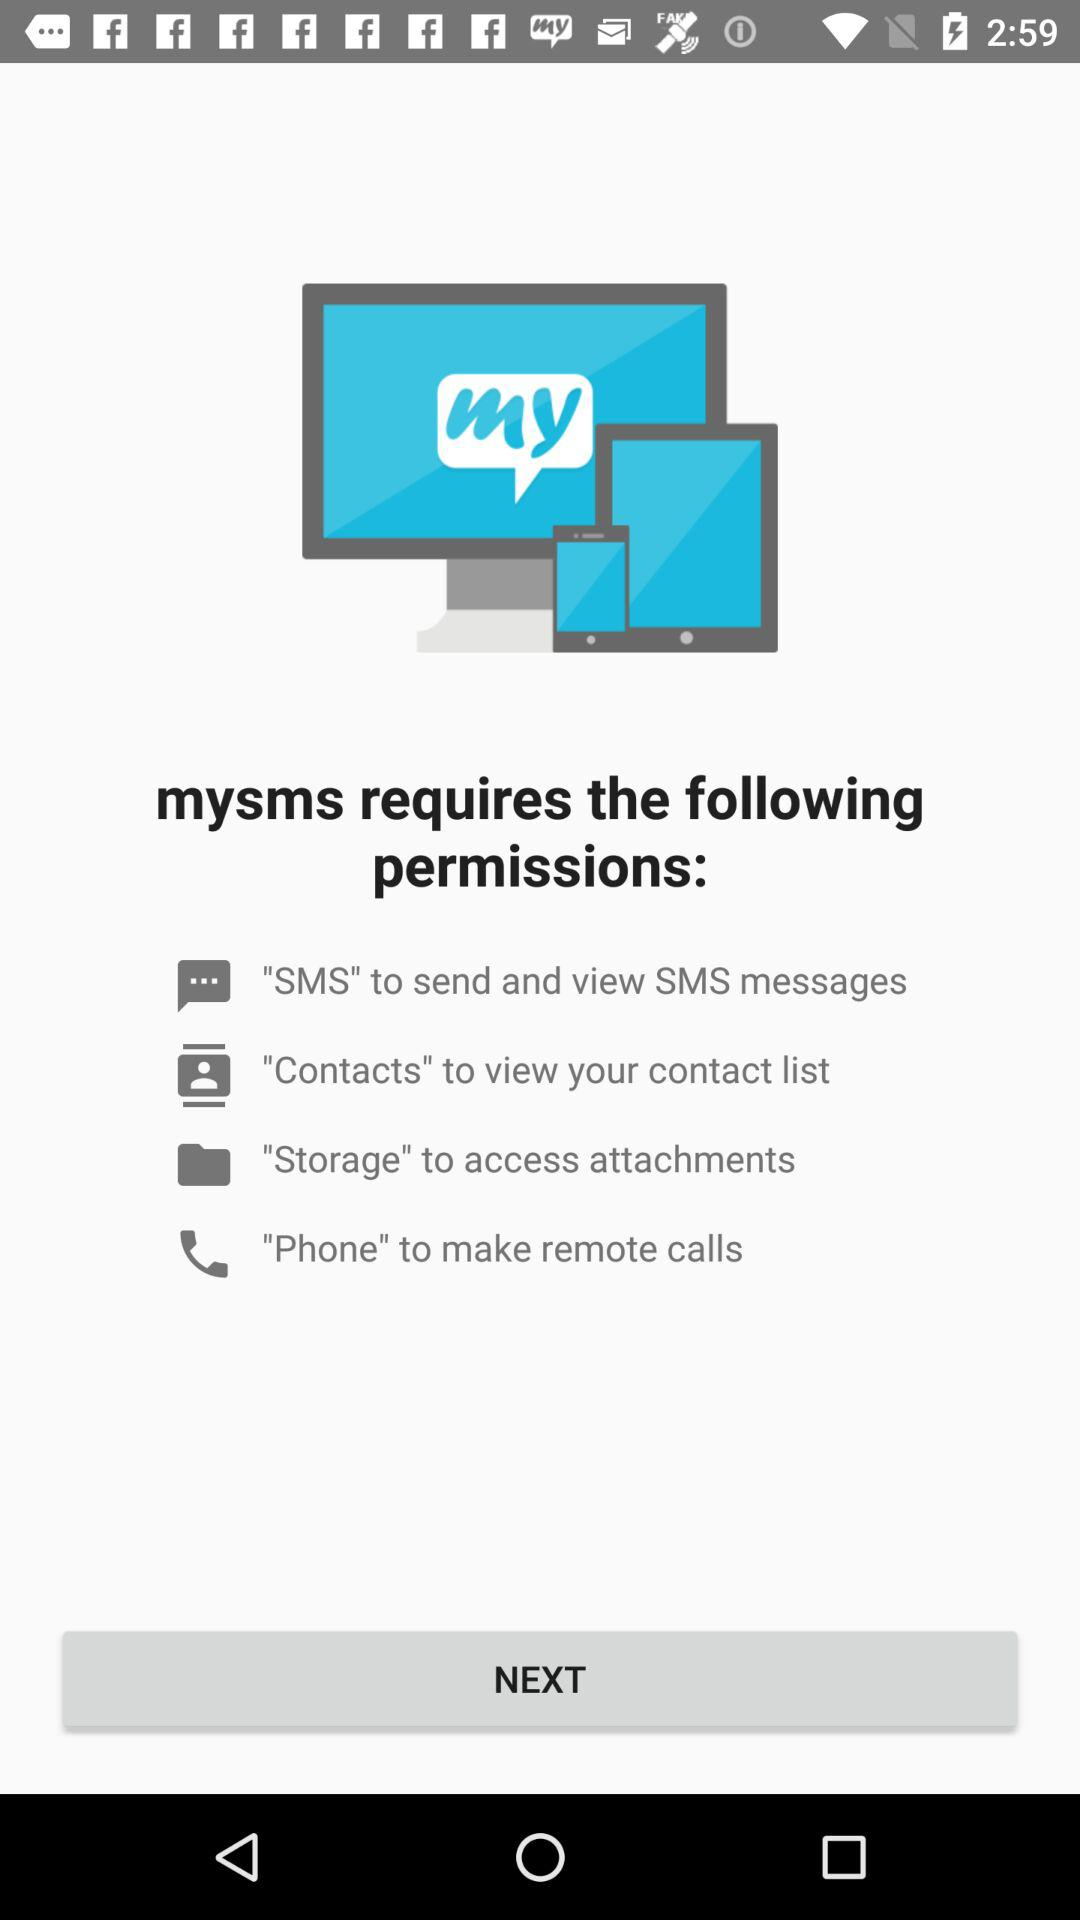How many permissions does the app require?
Answer the question using a single word or phrase. 4 